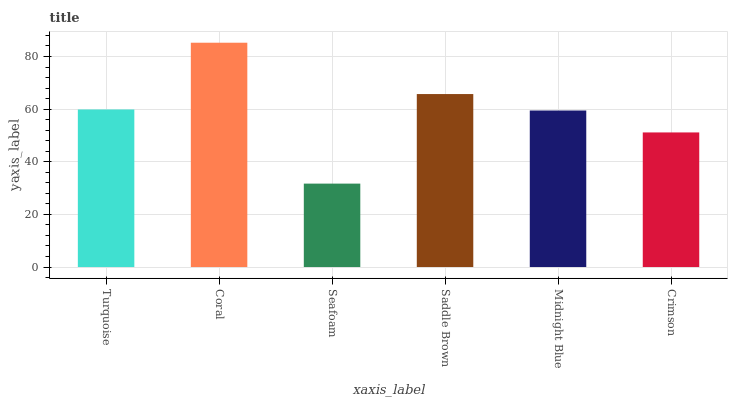Is Seafoam the minimum?
Answer yes or no. Yes. Is Coral the maximum?
Answer yes or no. Yes. Is Coral the minimum?
Answer yes or no. No. Is Seafoam the maximum?
Answer yes or no. No. Is Coral greater than Seafoam?
Answer yes or no. Yes. Is Seafoam less than Coral?
Answer yes or no. Yes. Is Seafoam greater than Coral?
Answer yes or no. No. Is Coral less than Seafoam?
Answer yes or no. No. Is Turquoise the high median?
Answer yes or no. Yes. Is Midnight Blue the low median?
Answer yes or no. Yes. Is Midnight Blue the high median?
Answer yes or no. No. Is Turquoise the low median?
Answer yes or no. No. 